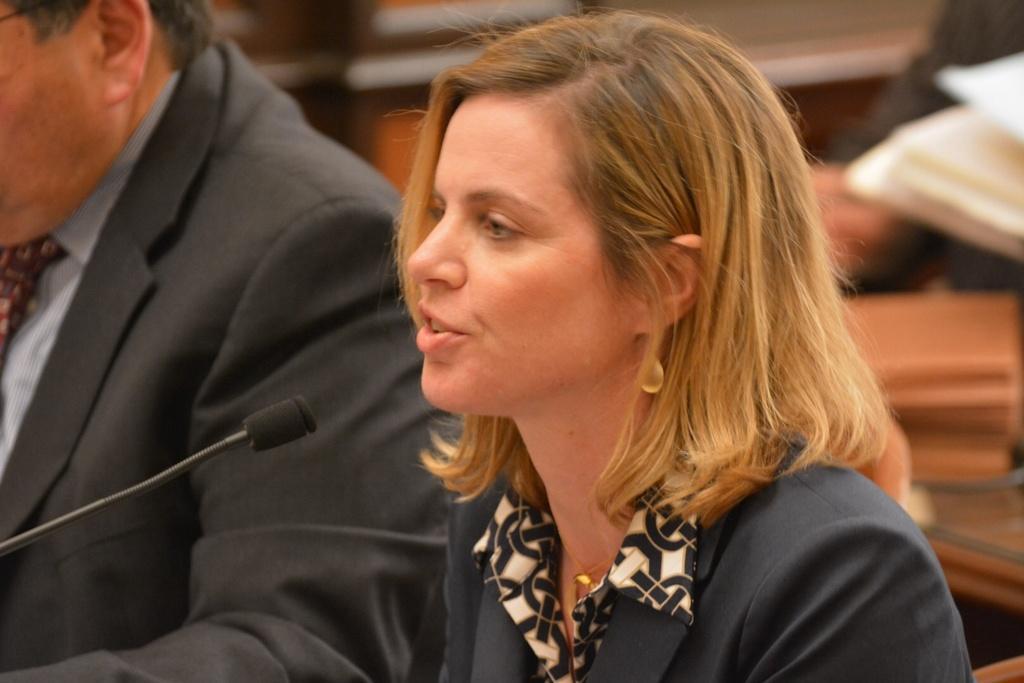How would you summarize this image in a sentence or two? In this image we can see two people are sitting, one microphone, one book, some objects on the table, the background is blurred, one woman sitting on the chair and talking. 